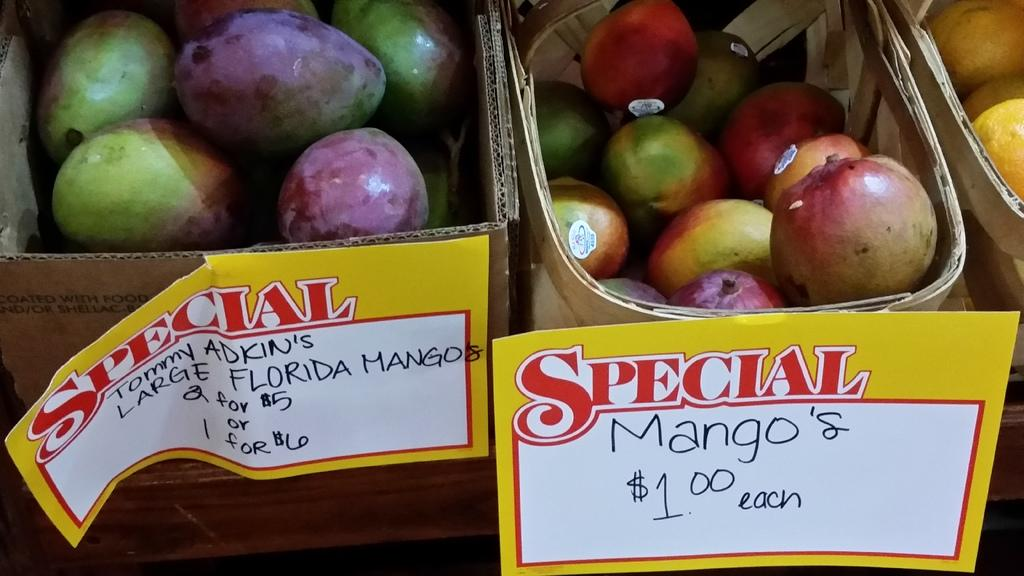What type of container is present in the image? There is a cardboard box in the image. What other containers can be seen in the image? There are baskets in the image. What are the cardboard box and baskets holding? The cardboard box and baskets contain fruits. What is placed in front of the cardboard box and baskets? There are stickers in front of the cardboard box and baskets. How does the cardboard box express regret in the image? The cardboard box does not express regret in the image, as it is an inanimate object and cannot experience emotions. 